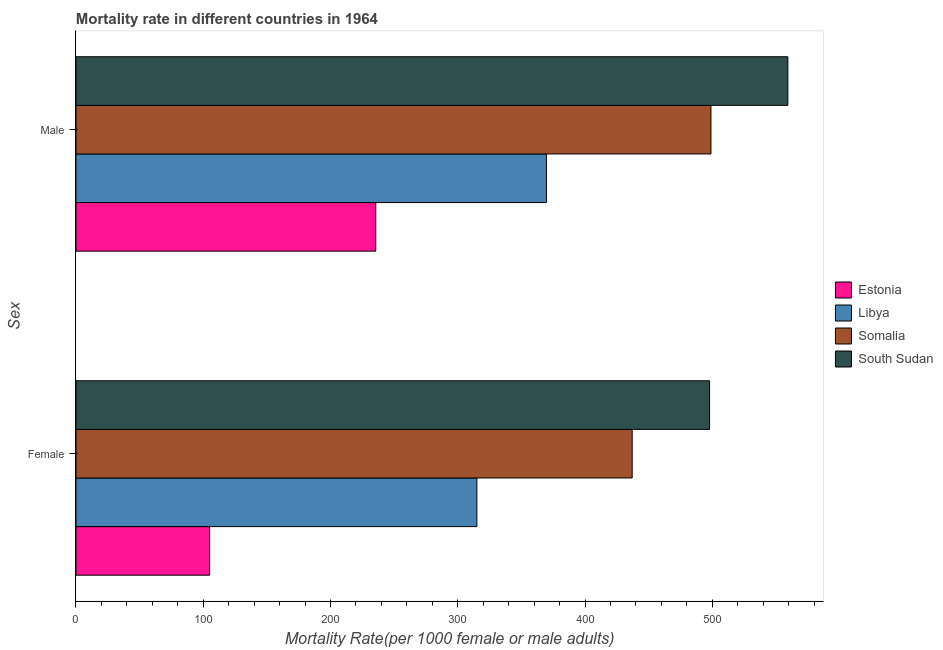How many different coloured bars are there?
Ensure brevity in your answer.  4. How many groups of bars are there?
Your answer should be very brief. 2. Are the number of bars per tick equal to the number of legend labels?
Make the answer very short. Yes. Are the number of bars on each tick of the Y-axis equal?
Give a very brief answer. Yes. How many bars are there on the 2nd tick from the top?
Offer a very short reply. 4. How many bars are there on the 2nd tick from the bottom?
Give a very brief answer. 4. What is the female mortality rate in Libya?
Your response must be concise. 315.01. Across all countries, what is the maximum female mortality rate?
Offer a very short reply. 497.86. Across all countries, what is the minimum male mortality rate?
Ensure brevity in your answer.  235.56. In which country was the female mortality rate maximum?
Keep it short and to the point. South Sudan. In which country was the female mortality rate minimum?
Keep it short and to the point. Estonia. What is the total female mortality rate in the graph?
Keep it short and to the point. 1354.9. What is the difference between the female mortality rate in South Sudan and that in Libya?
Your answer should be very brief. 182.85. What is the difference between the female mortality rate in Estonia and the male mortality rate in Libya?
Give a very brief answer. -264.69. What is the average female mortality rate per country?
Make the answer very short. 338.72. What is the difference between the female mortality rate and male mortality rate in Somalia?
Your answer should be very brief. -61.9. What is the ratio of the male mortality rate in South Sudan to that in Somalia?
Your response must be concise. 1.12. Is the male mortality rate in South Sudan less than that in Somalia?
Your answer should be very brief. No. What does the 3rd bar from the top in Female represents?
Give a very brief answer. Libya. What does the 2nd bar from the bottom in Female represents?
Give a very brief answer. Libya. How many bars are there?
Your response must be concise. 8. Are the values on the major ticks of X-axis written in scientific E-notation?
Ensure brevity in your answer.  No. Does the graph contain any zero values?
Make the answer very short. No. How are the legend labels stacked?
Offer a terse response. Vertical. What is the title of the graph?
Provide a short and direct response. Mortality rate in different countries in 1964. What is the label or title of the X-axis?
Your response must be concise. Mortality Rate(per 1000 female or male adults). What is the label or title of the Y-axis?
Your answer should be compact. Sex. What is the Mortality Rate(per 1000 female or male adults) in Estonia in Female?
Keep it short and to the point. 104.99. What is the Mortality Rate(per 1000 female or male adults) of Libya in Female?
Offer a very short reply. 315.01. What is the Mortality Rate(per 1000 female or male adults) of Somalia in Female?
Your answer should be very brief. 437.04. What is the Mortality Rate(per 1000 female or male adults) in South Sudan in Female?
Make the answer very short. 497.86. What is the Mortality Rate(per 1000 female or male adults) of Estonia in Male?
Make the answer very short. 235.56. What is the Mortality Rate(per 1000 female or male adults) in Libya in Male?
Provide a succinct answer. 369.68. What is the Mortality Rate(per 1000 female or male adults) in Somalia in Male?
Your answer should be very brief. 498.94. What is the Mortality Rate(per 1000 female or male adults) of South Sudan in Male?
Your response must be concise. 559.36. Across all Sex, what is the maximum Mortality Rate(per 1000 female or male adults) in Estonia?
Your response must be concise. 235.56. Across all Sex, what is the maximum Mortality Rate(per 1000 female or male adults) in Libya?
Your answer should be compact. 369.68. Across all Sex, what is the maximum Mortality Rate(per 1000 female or male adults) of Somalia?
Provide a short and direct response. 498.94. Across all Sex, what is the maximum Mortality Rate(per 1000 female or male adults) of South Sudan?
Offer a very short reply. 559.36. Across all Sex, what is the minimum Mortality Rate(per 1000 female or male adults) of Estonia?
Provide a short and direct response. 104.99. Across all Sex, what is the minimum Mortality Rate(per 1000 female or male adults) of Libya?
Give a very brief answer. 315.01. Across all Sex, what is the minimum Mortality Rate(per 1000 female or male adults) of Somalia?
Provide a succinct answer. 437.04. Across all Sex, what is the minimum Mortality Rate(per 1000 female or male adults) of South Sudan?
Offer a terse response. 497.86. What is the total Mortality Rate(per 1000 female or male adults) in Estonia in the graph?
Offer a terse response. 340.55. What is the total Mortality Rate(per 1000 female or male adults) in Libya in the graph?
Your answer should be compact. 684.69. What is the total Mortality Rate(per 1000 female or male adults) of Somalia in the graph?
Your answer should be very brief. 935.98. What is the total Mortality Rate(per 1000 female or male adults) of South Sudan in the graph?
Provide a succinct answer. 1057.22. What is the difference between the Mortality Rate(per 1000 female or male adults) in Estonia in Female and that in Male?
Ensure brevity in your answer.  -130.57. What is the difference between the Mortality Rate(per 1000 female or male adults) of Libya in Female and that in Male?
Your answer should be compact. -54.67. What is the difference between the Mortality Rate(per 1000 female or male adults) of Somalia in Female and that in Male?
Provide a succinct answer. -61.9. What is the difference between the Mortality Rate(per 1000 female or male adults) in South Sudan in Female and that in Male?
Your response must be concise. -61.5. What is the difference between the Mortality Rate(per 1000 female or male adults) in Estonia in Female and the Mortality Rate(per 1000 female or male adults) in Libya in Male?
Your answer should be compact. -264.69. What is the difference between the Mortality Rate(per 1000 female or male adults) in Estonia in Female and the Mortality Rate(per 1000 female or male adults) in Somalia in Male?
Keep it short and to the point. -393.95. What is the difference between the Mortality Rate(per 1000 female or male adults) in Estonia in Female and the Mortality Rate(per 1000 female or male adults) in South Sudan in Male?
Your answer should be very brief. -454.37. What is the difference between the Mortality Rate(per 1000 female or male adults) of Libya in Female and the Mortality Rate(per 1000 female or male adults) of Somalia in Male?
Your answer should be very brief. -183.93. What is the difference between the Mortality Rate(per 1000 female or male adults) in Libya in Female and the Mortality Rate(per 1000 female or male adults) in South Sudan in Male?
Your response must be concise. -244.35. What is the difference between the Mortality Rate(per 1000 female or male adults) in Somalia in Female and the Mortality Rate(per 1000 female or male adults) in South Sudan in Male?
Make the answer very short. -122.31. What is the average Mortality Rate(per 1000 female or male adults) in Estonia per Sex?
Your response must be concise. 170.27. What is the average Mortality Rate(per 1000 female or male adults) of Libya per Sex?
Offer a terse response. 342.34. What is the average Mortality Rate(per 1000 female or male adults) in Somalia per Sex?
Ensure brevity in your answer.  467.99. What is the average Mortality Rate(per 1000 female or male adults) of South Sudan per Sex?
Give a very brief answer. 528.61. What is the difference between the Mortality Rate(per 1000 female or male adults) of Estonia and Mortality Rate(per 1000 female or male adults) of Libya in Female?
Provide a succinct answer. -210.02. What is the difference between the Mortality Rate(per 1000 female or male adults) of Estonia and Mortality Rate(per 1000 female or male adults) of Somalia in Female?
Keep it short and to the point. -332.06. What is the difference between the Mortality Rate(per 1000 female or male adults) of Estonia and Mortality Rate(per 1000 female or male adults) of South Sudan in Female?
Your answer should be very brief. -392.87. What is the difference between the Mortality Rate(per 1000 female or male adults) in Libya and Mortality Rate(per 1000 female or male adults) in Somalia in Female?
Your response must be concise. -122.04. What is the difference between the Mortality Rate(per 1000 female or male adults) in Libya and Mortality Rate(per 1000 female or male adults) in South Sudan in Female?
Keep it short and to the point. -182.85. What is the difference between the Mortality Rate(per 1000 female or male adults) in Somalia and Mortality Rate(per 1000 female or male adults) in South Sudan in Female?
Your answer should be compact. -60.82. What is the difference between the Mortality Rate(per 1000 female or male adults) of Estonia and Mortality Rate(per 1000 female or male adults) of Libya in Male?
Your answer should be very brief. -134.12. What is the difference between the Mortality Rate(per 1000 female or male adults) in Estonia and Mortality Rate(per 1000 female or male adults) in Somalia in Male?
Give a very brief answer. -263.38. What is the difference between the Mortality Rate(per 1000 female or male adults) of Estonia and Mortality Rate(per 1000 female or male adults) of South Sudan in Male?
Provide a succinct answer. -323.8. What is the difference between the Mortality Rate(per 1000 female or male adults) in Libya and Mortality Rate(per 1000 female or male adults) in Somalia in Male?
Provide a succinct answer. -129.26. What is the difference between the Mortality Rate(per 1000 female or male adults) in Libya and Mortality Rate(per 1000 female or male adults) in South Sudan in Male?
Give a very brief answer. -189.68. What is the difference between the Mortality Rate(per 1000 female or male adults) in Somalia and Mortality Rate(per 1000 female or male adults) in South Sudan in Male?
Your answer should be compact. -60.42. What is the ratio of the Mortality Rate(per 1000 female or male adults) of Estonia in Female to that in Male?
Provide a succinct answer. 0.45. What is the ratio of the Mortality Rate(per 1000 female or male adults) of Libya in Female to that in Male?
Ensure brevity in your answer.  0.85. What is the ratio of the Mortality Rate(per 1000 female or male adults) in Somalia in Female to that in Male?
Offer a very short reply. 0.88. What is the ratio of the Mortality Rate(per 1000 female or male adults) of South Sudan in Female to that in Male?
Provide a short and direct response. 0.89. What is the difference between the highest and the second highest Mortality Rate(per 1000 female or male adults) of Estonia?
Provide a succinct answer. 130.57. What is the difference between the highest and the second highest Mortality Rate(per 1000 female or male adults) in Libya?
Provide a short and direct response. 54.67. What is the difference between the highest and the second highest Mortality Rate(per 1000 female or male adults) in Somalia?
Provide a short and direct response. 61.9. What is the difference between the highest and the second highest Mortality Rate(per 1000 female or male adults) of South Sudan?
Keep it short and to the point. 61.5. What is the difference between the highest and the lowest Mortality Rate(per 1000 female or male adults) in Estonia?
Your answer should be very brief. 130.57. What is the difference between the highest and the lowest Mortality Rate(per 1000 female or male adults) in Libya?
Provide a short and direct response. 54.67. What is the difference between the highest and the lowest Mortality Rate(per 1000 female or male adults) in Somalia?
Your answer should be very brief. 61.9. What is the difference between the highest and the lowest Mortality Rate(per 1000 female or male adults) of South Sudan?
Provide a succinct answer. 61.5. 